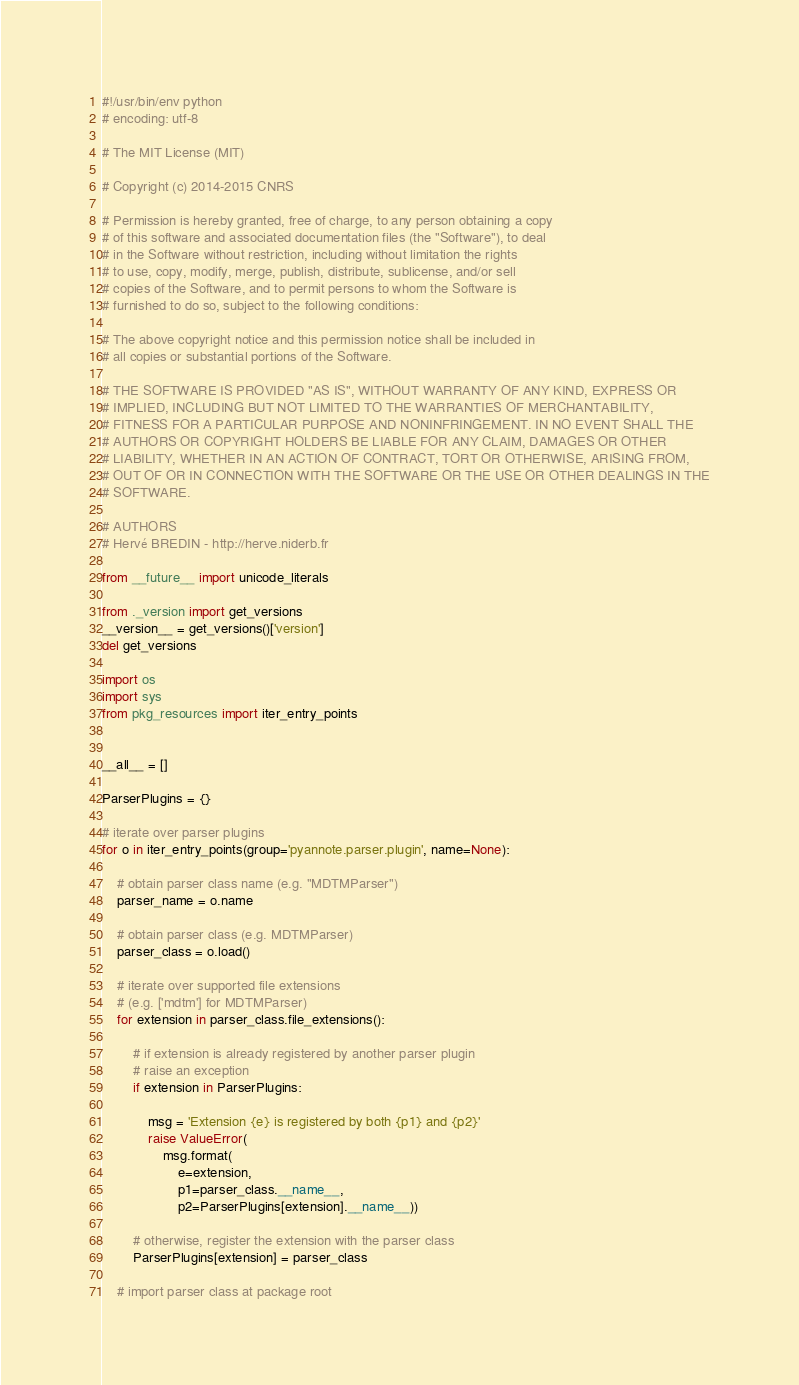Convert code to text. <code><loc_0><loc_0><loc_500><loc_500><_Python_>#!/usr/bin/env python
# encoding: utf-8

# The MIT License (MIT)

# Copyright (c) 2014-2015 CNRS

# Permission is hereby granted, free of charge, to any person obtaining a copy
# of this software and associated documentation files (the "Software"), to deal
# in the Software without restriction, including without limitation the rights
# to use, copy, modify, merge, publish, distribute, sublicense, and/or sell
# copies of the Software, and to permit persons to whom the Software is
# furnished to do so, subject to the following conditions:

# The above copyright notice and this permission notice shall be included in
# all copies or substantial portions of the Software.

# THE SOFTWARE IS PROVIDED "AS IS", WITHOUT WARRANTY OF ANY KIND, EXPRESS OR
# IMPLIED, INCLUDING BUT NOT LIMITED TO THE WARRANTIES OF MERCHANTABILITY,
# FITNESS FOR A PARTICULAR PURPOSE AND NONINFRINGEMENT. IN NO EVENT SHALL THE
# AUTHORS OR COPYRIGHT HOLDERS BE LIABLE FOR ANY CLAIM, DAMAGES OR OTHER
# LIABILITY, WHETHER IN AN ACTION OF CONTRACT, TORT OR OTHERWISE, ARISING FROM,
# OUT OF OR IN CONNECTION WITH THE SOFTWARE OR THE USE OR OTHER DEALINGS IN THE
# SOFTWARE.

# AUTHORS
# Hervé BREDIN - http://herve.niderb.fr

from __future__ import unicode_literals

from ._version import get_versions
__version__ = get_versions()['version']
del get_versions

import os
import sys
from pkg_resources import iter_entry_points


__all__ = []

ParserPlugins = {}

# iterate over parser plugins
for o in iter_entry_points(group='pyannote.parser.plugin', name=None):

    # obtain parser class name (e.g. "MDTMParser")
    parser_name = o.name

    # obtain parser class (e.g. MDTMParser)
    parser_class = o.load()

    # iterate over supported file extensions
    # (e.g. ['mdtm'] for MDTMParser)
    for extension in parser_class.file_extensions():

        # if extension is already registered by another parser plugin
        # raise an exception
        if extension in ParserPlugins:

            msg = 'Extension {e} is registered by both {p1} and {p2}'
            raise ValueError(
                msg.format(
                    e=extension,
                    p1=parser_class.__name__,
                    p2=ParserPlugins[extension].__name__))

        # otherwise, register the extension with the parser class
        ParserPlugins[extension] = parser_class

    # import parser class at package root</code> 